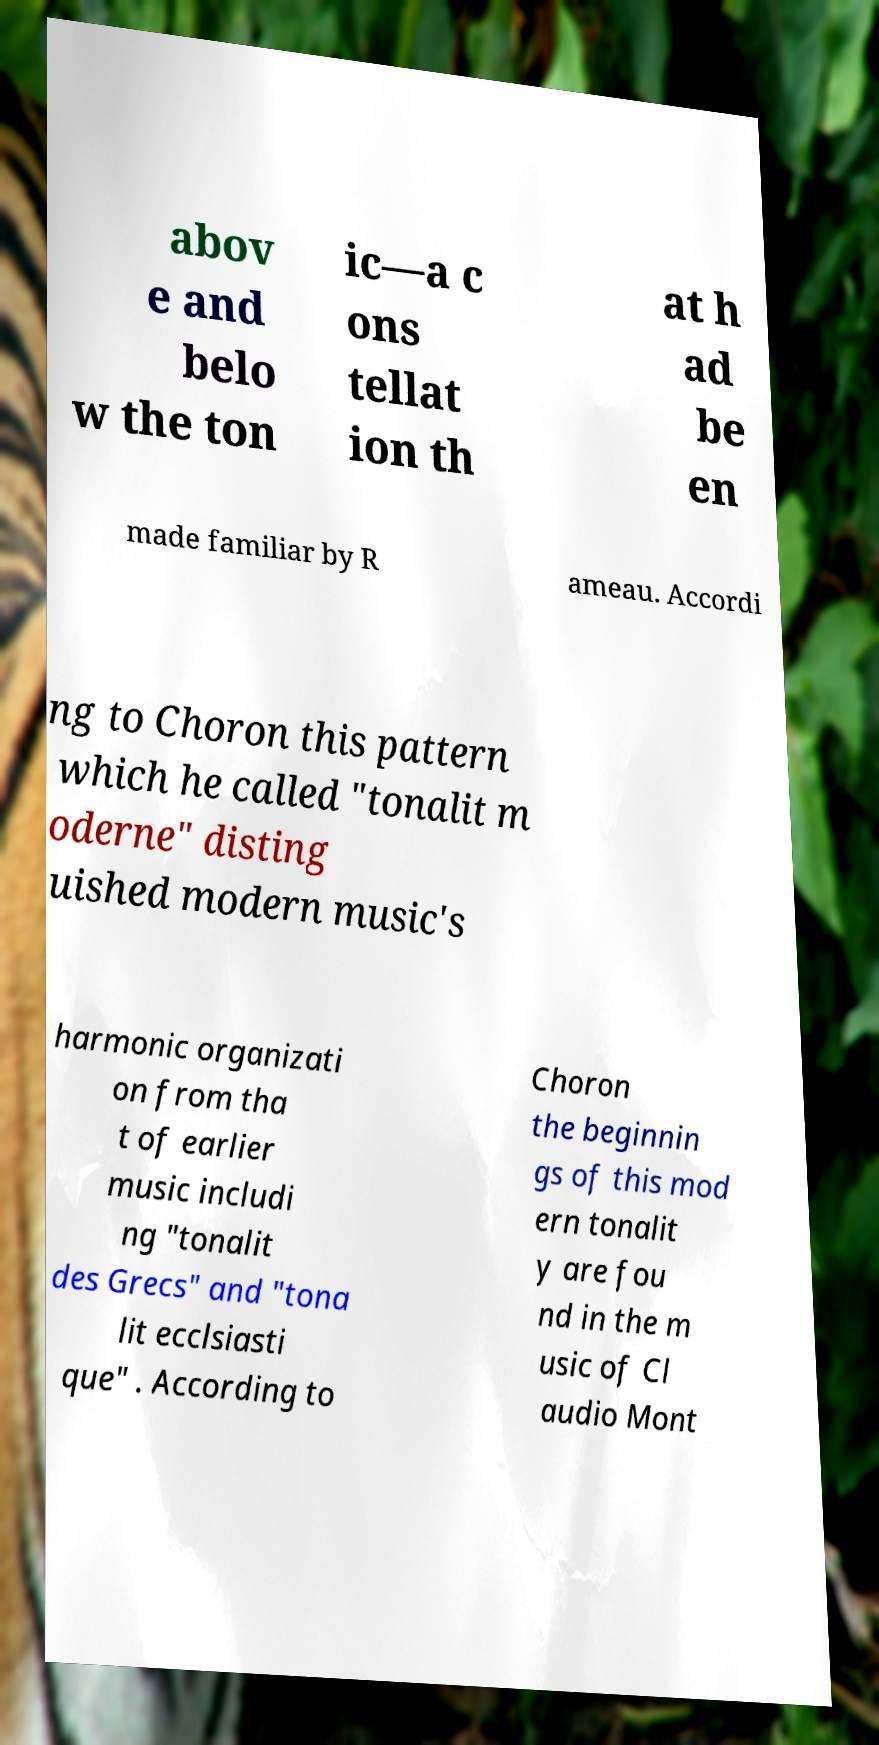Can you accurately transcribe the text from the provided image for me? abov e and belo w the ton ic—a c ons tellat ion th at h ad be en made familiar by R ameau. Accordi ng to Choron this pattern which he called "tonalit m oderne" disting uished modern music's harmonic organizati on from tha t of earlier music includi ng "tonalit des Grecs" and "tona lit ecclsiasti que" . According to Choron the beginnin gs of this mod ern tonalit y are fou nd in the m usic of Cl audio Mont 